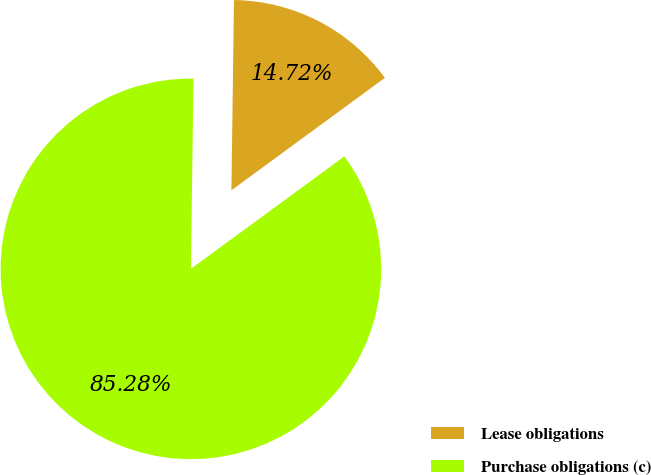<chart> <loc_0><loc_0><loc_500><loc_500><pie_chart><fcel>Lease obligations<fcel>Purchase obligations (c)<nl><fcel>14.72%<fcel>85.28%<nl></chart> 